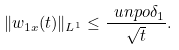Convert formula to latex. <formula><loc_0><loc_0><loc_500><loc_500>\| w _ { 1 x } ( t ) \| _ { L ^ { 1 } } \leq \frac { \ u n p o \delta _ { 1 } } { \sqrt { t } } .</formula> 